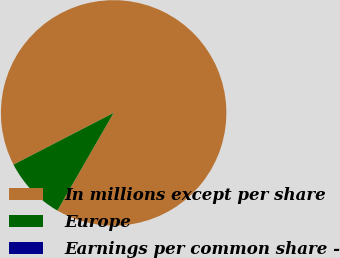Convert chart. <chart><loc_0><loc_0><loc_500><loc_500><pie_chart><fcel>In millions except per share<fcel>Europe<fcel>Earnings per common share -<nl><fcel>90.9%<fcel>9.09%<fcel>0.0%<nl></chart> 